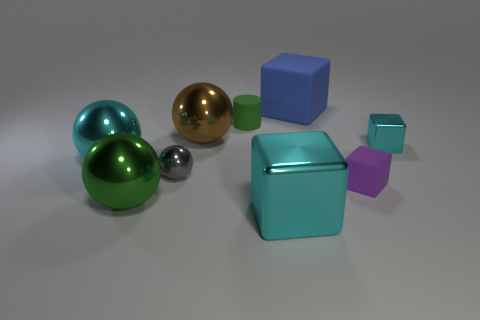What shape is the small object that is both left of the blue matte thing and in front of the large brown object? sphere 